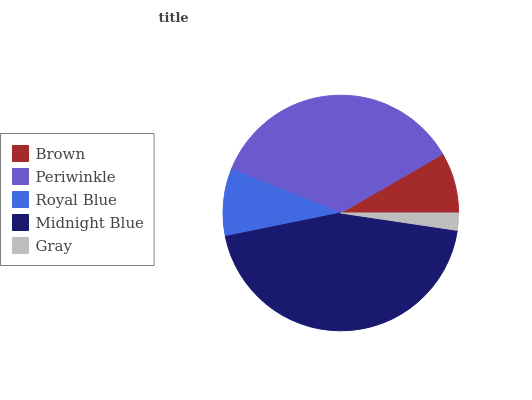Is Gray the minimum?
Answer yes or no. Yes. Is Midnight Blue the maximum?
Answer yes or no. Yes. Is Periwinkle the minimum?
Answer yes or no. No. Is Periwinkle the maximum?
Answer yes or no. No. Is Periwinkle greater than Brown?
Answer yes or no. Yes. Is Brown less than Periwinkle?
Answer yes or no. Yes. Is Brown greater than Periwinkle?
Answer yes or no. No. Is Periwinkle less than Brown?
Answer yes or no. No. Is Royal Blue the high median?
Answer yes or no. Yes. Is Royal Blue the low median?
Answer yes or no. Yes. Is Periwinkle the high median?
Answer yes or no. No. Is Gray the low median?
Answer yes or no. No. 